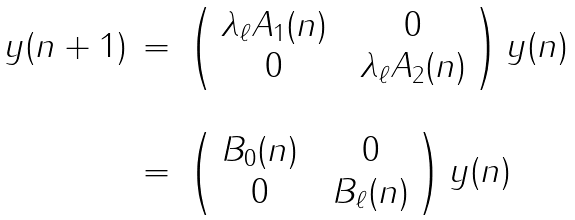<formula> <loc_0><loc_0><loc_500><loc_500>\begin{array} { r c l } y ( n + 1 ) & = & \left ( \begin{array} { c c c } \lambda _ { \ell } A _ { 1 } ( n ) & & 0 \\ 0 & & \lambda _ { \ell } A _ { 2 } ( n ) \end{array} \right ) y ( n ) \\ \\ & = & \left ( \begin{array} { c c c } B _ { 0 } ( n ) & & 0 \\ 0 & & B _ { \ell } ( n ) \end{array} \right ) y ( n ) \end{array}</formula> 